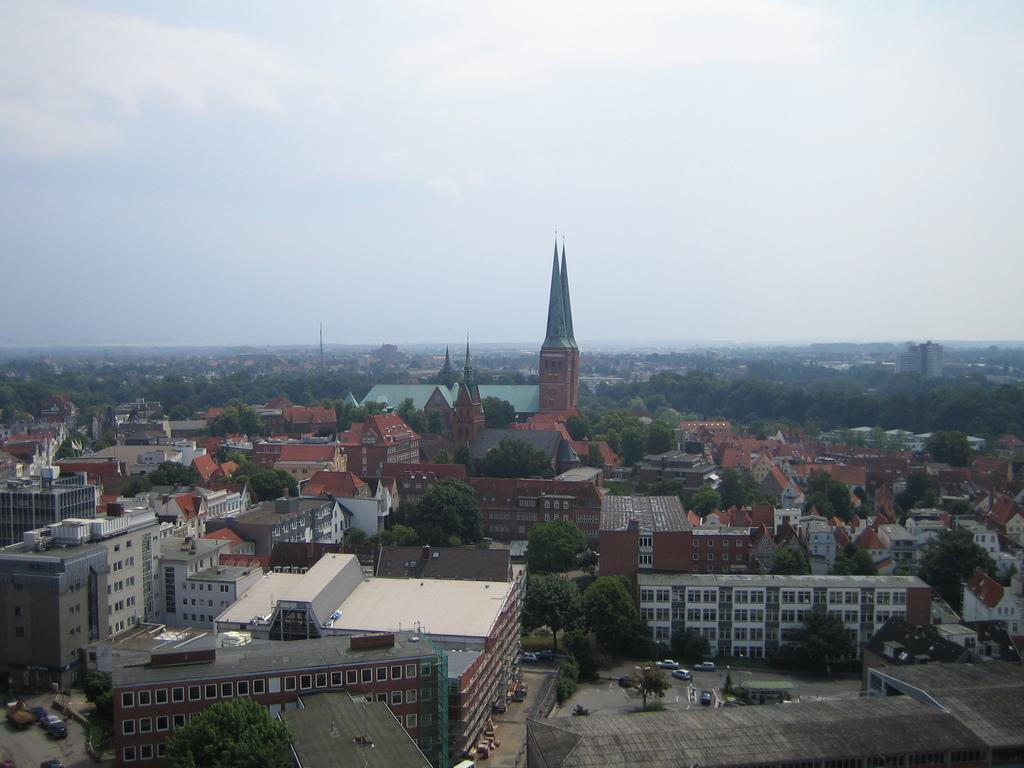What type of view is shown in the image? The image is an aerial view. What structures can be seen in the image? There are houses and towers in the image. What type of vegetation is present in the image? There are trees in the image. What else can be seen in the image besides structures and vegetation? There are vehicles in the image. What is visible in the background of the image? The sky is visible in the image. How does the image show the scale of the debt in the area? The image does not show the scale of any debt; it is an aerial view of structures, trees, vehicles, and the sky. What type of cough can be heard from the towers in the image? There is no sound, including coughing, present in the image; it is a still photograph. 